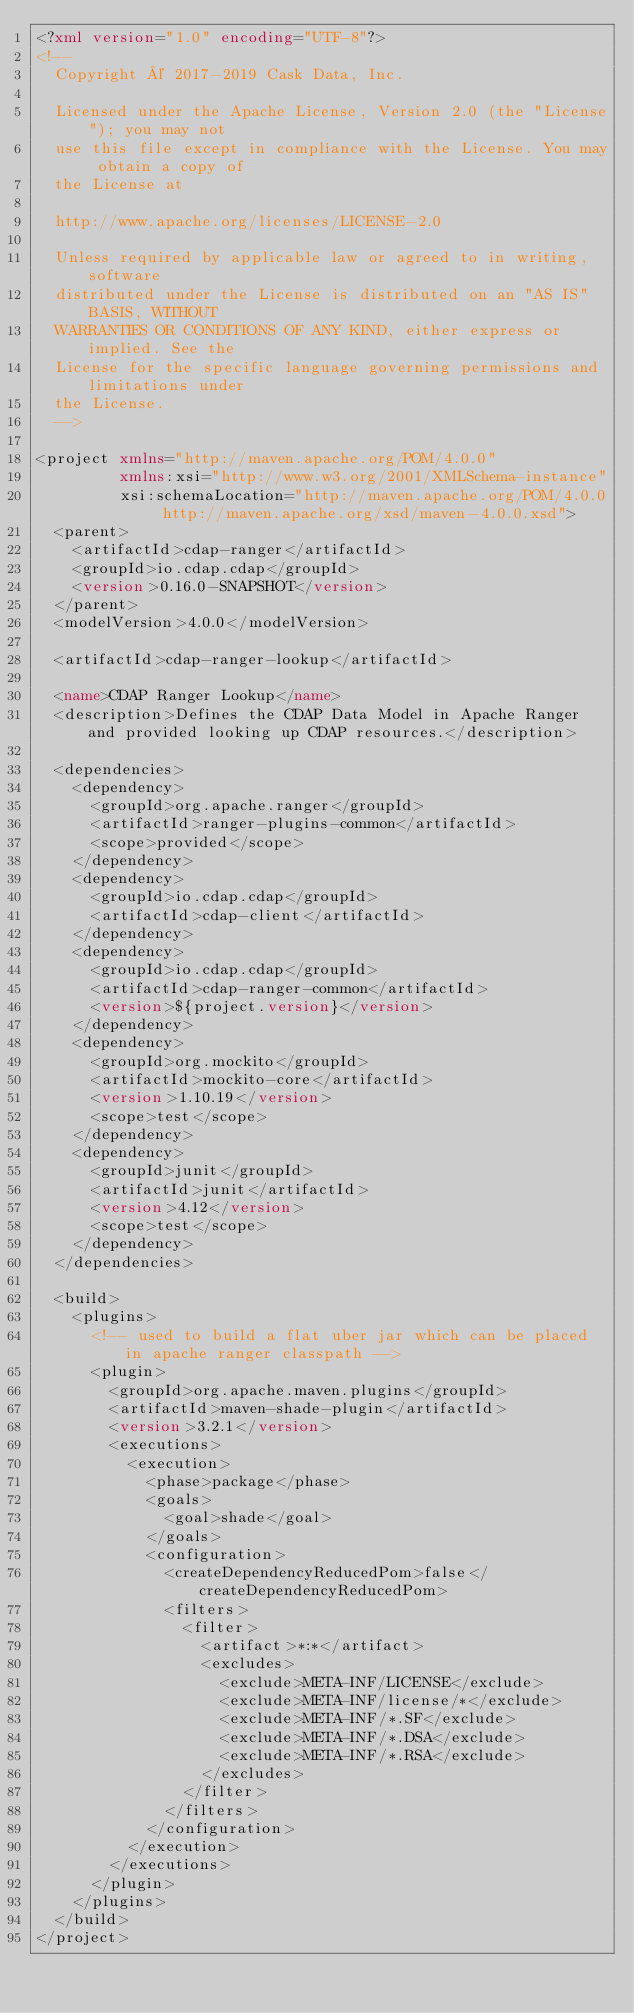Convert code to text. <code><loc_0><loc_0><loc_500><loc_500><_XML_><?xml version="1.0" encoding="UTF-8"?>
<!--
  Copyright © 2017-2019 Cask Data, Inc.

  Licensed under the Apache License, Version 2.0 (the "License"); you may not
  use this file except in compliance with the License. You may obtain a copy of
  the License at

  http://www.apache.org/licenses/LICENSE-2.0

  Unless required by applicable law or agreed to in writing, software
  distributed under the License is distributed on an "AS IS" BASIS, WITHOUT
  WARRANTIES OR CONDITIONS OF ANY KIND, either express or implied. See the
  License for the specific language governing permissions and limitations under
  the License.
  -->

<project xmlns="http://maven.apache.org/POM/4.0.0"
         xmlns:xsi="http://www.w3.org/2001/XMLSchema-instance"
         xsi:schemaLocation="http://maven.apache.org/POM/4.0.0 http://maven.apache.org/xsd/maven-4.0.0.xsd">
  <parent>
    <artifactId>cdap-ranger</artifactId>
    <groupId>io.cdap.cdap</groupId>
    <version>0.16.0-SNAPSHOT</version>
  </parent>
  <modelVersion>4.0.0</modelVersion>

  <artifactId>cdap-ranger-lookup</artifactId>

  <name>CDAP Ranger Lookup</name>
  <description>Defines the CDAP Data Model in Apache Ranger and provided looking up CDAP resources.</description>

  <dependencies>
    <dependency>
      <groupId>org.apache.ranger</groupId>
      <artifactId>ranger-plugins-common</artifactId>
      <scope>provided</scope>
    </dependency>
    <dependency>
      <groupId>io.cdap.cdap</groupId>
      <artifactId>cdap-client</artifactId>
    </dependency>
    <dependency>
      <groupId>io.cdap.cdap</groupId>
      <artifactId>cdap-ranger-common</artifactId>
      <version>${project.version}</version>
    </dependency>
    <dependency>
      <groupId>org.mockito</groupId>
      <artifactId>mockito-core</artifactId>
      <version>1.10.19</version>
      <scope>test</scope>
    </dependency>
    <dependency>
      <groupId>junit</groupId>
      <artifactId>junit</artifactId>
      <version>4.12</version>
      <scope>test</scope>
    </dependency>
  </dependencies>

  <build>
    <plugins>
      <!-- used to build a flat uber jar which can be placed in apache ranger classpath -->
      <plugin>
        <groupId>org.apache.maven.plugins</groupId>
        <artifactId>maven-shade-plugin</artifactId>
        <version>3.2.1</version>
        <executions>
          <execution>
            <phase>package</phase>
            <goals>
              <goal>shade</goal>
            </goals>
            <configuration>
              <createDependencyReducedPom>false</createDependencyReducedPom>
              <filters>
                <filter>
                  <artifact>*:*</artifact>
                  <excludes>
                    <exclude>META-INF/LICENSE</exclude>
                    <exclude>META-INF/license/*</exclude>
                    <exclude>META-INF/*.SF</exclude>
                    <exclude>META-INF/*.DSA</exclude>
                    <exclude>META-INF/*.RSA</exclude>
                  </excludes>
                </filter>
              </filters>
            </configuration>
          </execution>
        </executions>
      </plugin>
    </plugins>
  </build>
</project>
</code> 